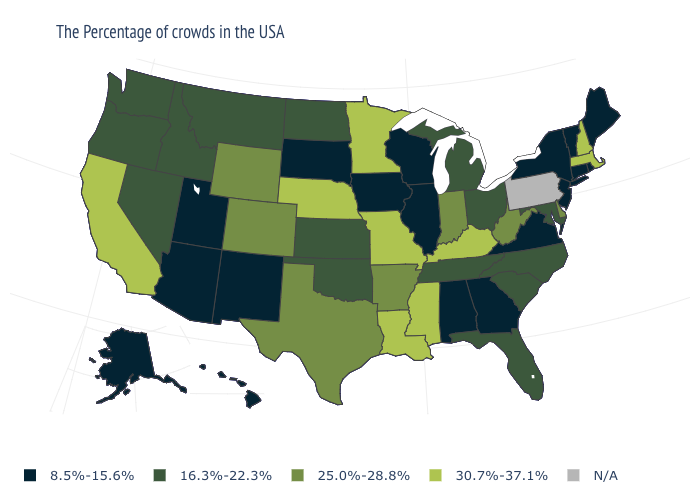What is the value of New York?
Short answer required. 8.5%-15.6%. What is the value of Oregon?
Be succinct. 16.3%-22.3%. Does Utah have the lowest value in the West?
Keep it brief. Yes. Is the legend a continuous bar?
Give a very brief answer. No. Name the states that have a value in the range 25.0%-28.8%?
Be succinct. Delaware, West Virginia, Indiana, Arkansas, Texas, Wyoming, Colorado. Which states hav the highest value in the West?
Give a very brief answer. California. What is the lowest value in the USA?
Answer briefly. 8.5%-15.6%. What is the value of Connecticut?
Write a very short answer. 8.5%-15.6%. What is the highest value in the West ?
Concise answer only. 30.7%-37.1%. Does West Virginia have the highest value in the USA?
Keep it brief. No. What is the value of South Dakota?
Answer briefly. 8.5%-15.6%. What is the value of Rhode Island?
Concise answer only. 8.5%-15.6%. 